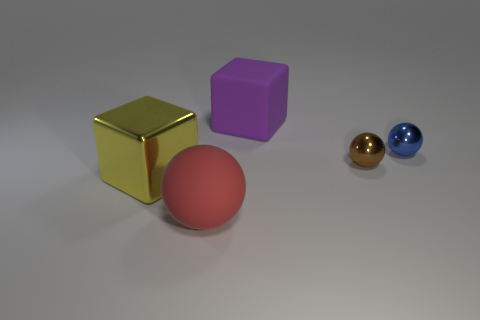Is there a shadow cast by the objects, and if so, what does that tell us about the light source? Yes, there are shadows cast by each object on the ground towards the left, which indicates that the light source is coming from the right side of the image. 